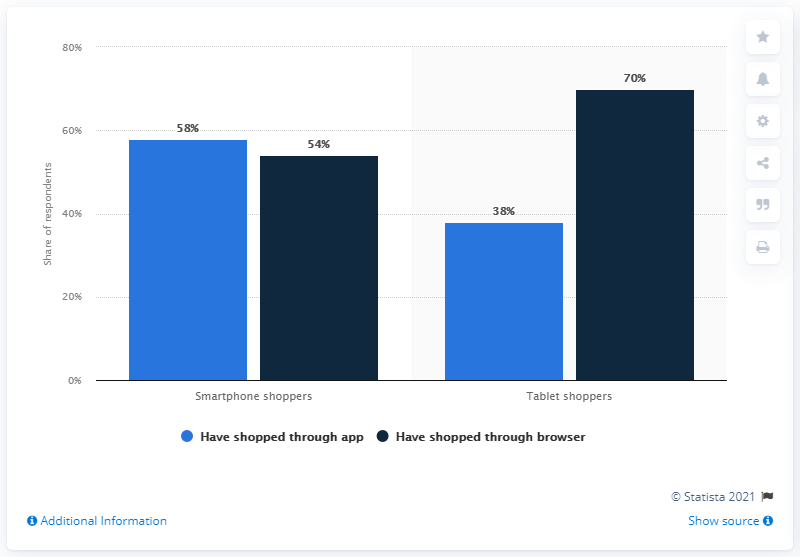Draw attention to some important aspects in this diagram. Smartphone shoppers demonstrated the least difference in preference between shopping through an app and browsing through a browser. The colored bar that is always above 50% is navy blue. 